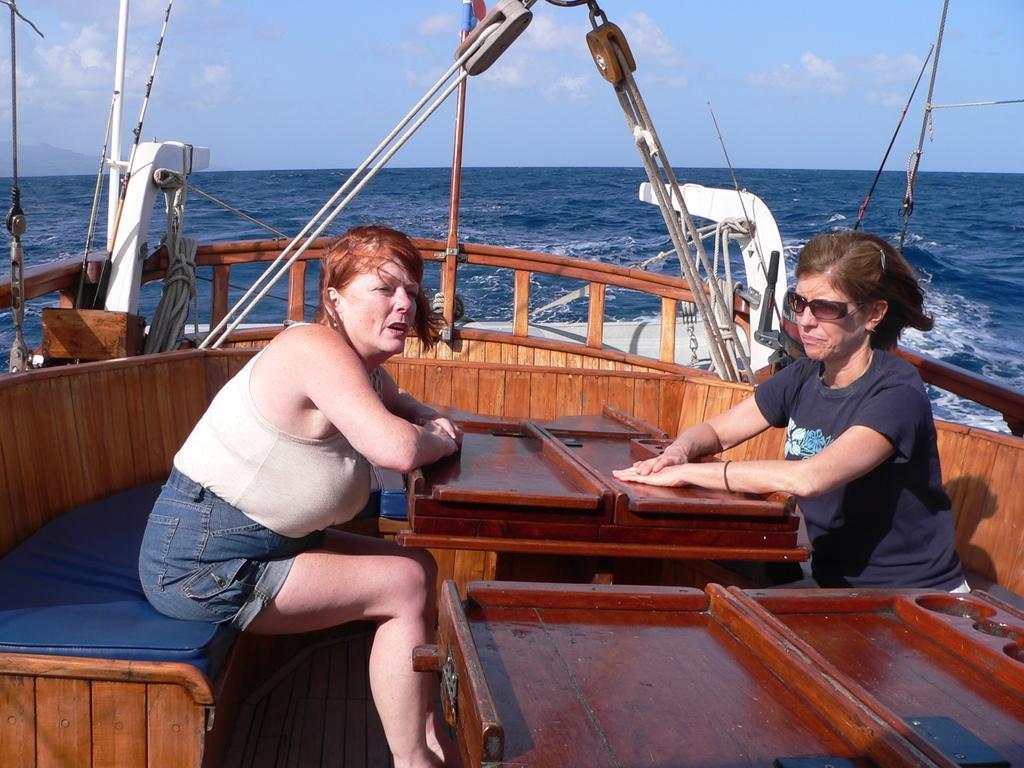Please provide a concise description of this image. In this image there is the sky towards the top of the image, there are clouds in the sky, there is water, there is a boat towards the bottom of the image, there are two women sitting in the boat. 